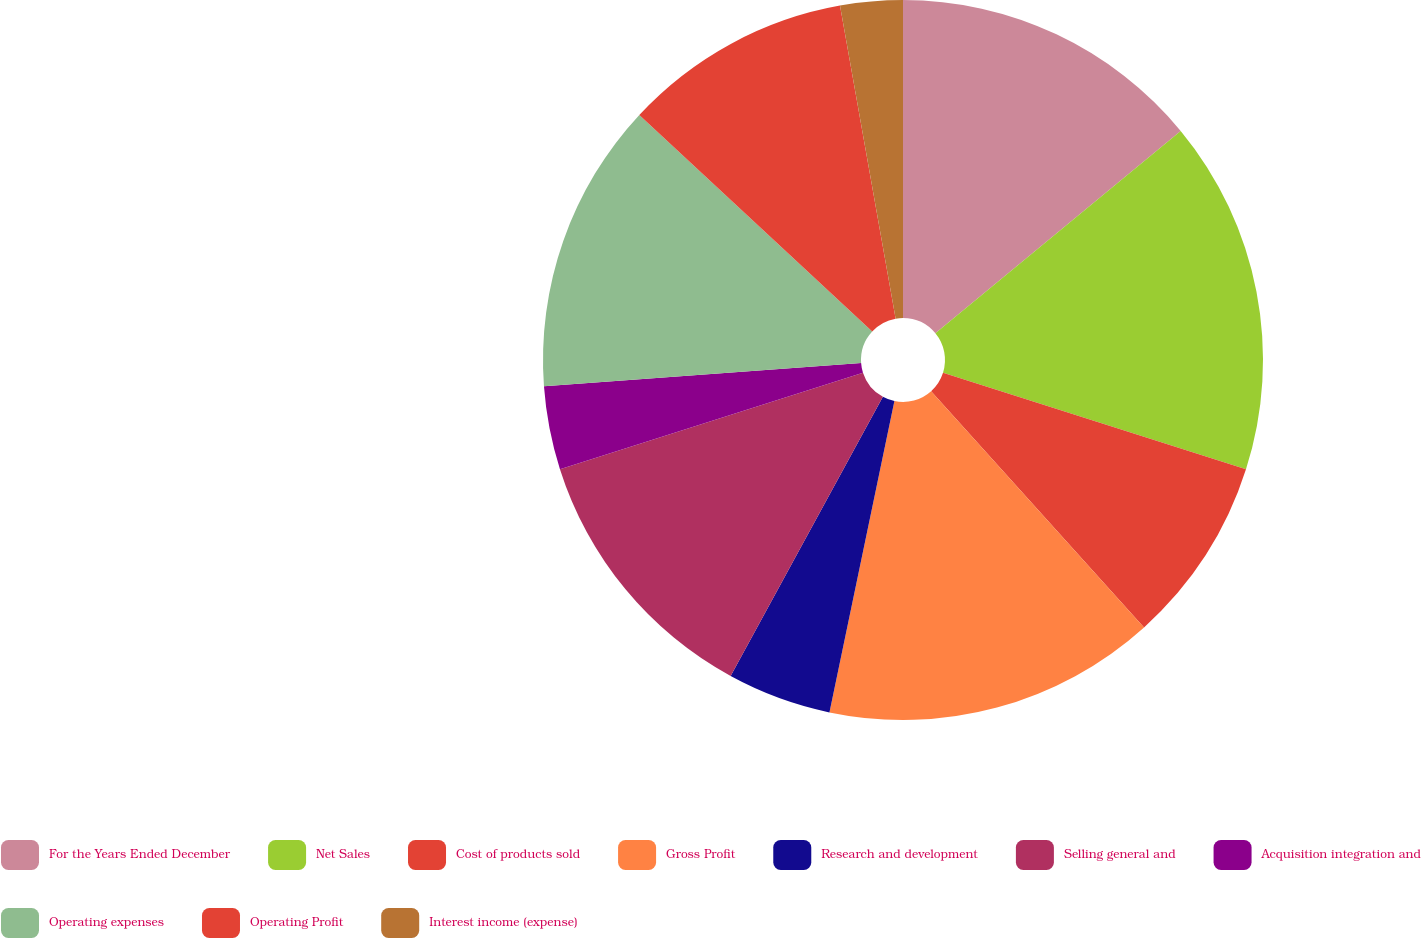Convert chart. <chart><loc_0><loc_0><loc_500><loc_500><pie_chart><fcel>For the Years Ended December<fcel>Net Sales<fcel>Cost of products sold<fcel>Gross Profit<fcel>Research and development<fcel>Selling general and<fcel>Acquisition integration and<fcel>Operating expenses<fcel>Operating Profit<fcel>Interest income (expense)<nl><fcel>14.02%<fcel>15.89%<fcel>8.41%<fcel>14.95%<fcel>4.67%<fcel>12.15%<fcel>3.74%<fcel>13.08%<fcel>10.28%<fcel>2.8%<nl></chart> 